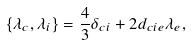Convert formula to latex. <formula><loc_0><loc_0><loc_500><loc_500>\{ \lambda _ { c } , \lambda _ { i } \} = \frac { 4 } { 3 } \delta _ { c i } + 2 d _ { c i e } \lambda _ { e } ,</formula> 